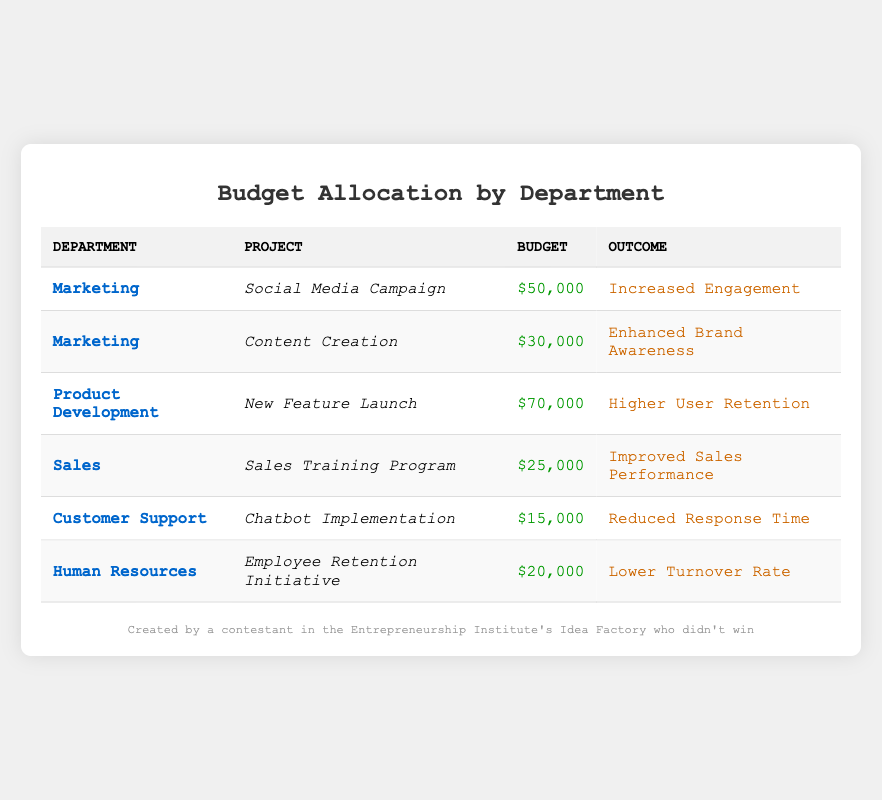What was the total budget allocated to the Marketing department? The Marketing department has two projects listed: the Social Media Campaign with a budget of 50,000 and Content Creation with a budget of 30,000. Adding these together gives 50,000 + 30,000 = 80,000.
Answer: 80,000 Which project had the lowest budget allocation? From the table, the Chatbot Implementation project from the Customer Support department had the lowest budget allocation of 15,000.
Answer: 15,000 Did the Product Development department have any project outcomes that improved user retention? Yes, the New Feature Launch project under the Product Development department had an outcome of higher user retention, which confirms this fact.
Answer: Yes What is the combined budget for projects that resulted in reduced response time or lower turnover rate? The Chatbot Implementation project had a budget of 15,000 (outcome: reduced response time) and the Employee Retention Initiative project had a budget of 20,000 (outcome: lower turnover rate). Adding these gives 15,000 + 20,000 = 35,000.
Answer: 35,000 Which department had a project with an outcome of improved sales performance, and what was the budget for it? The Sales department had a project titled Sales Training Program with a budget of 25,000, aimed at improving sales performance.
Answer: Sales, 25,000 Was the budget allocated for the Social Media Campaign greater than or equal to the budgets for all other projects combined? To evaluate this, the budget for the Social Media Campaign is 50,000. The sum of the other budgets is 30,000 (Content Creation) + 70,000 (New Feature Launch) + 25,000 (Sales Training Program) + 15,000 (Chatbot Implementation) + 20,000 (Employee Retention Initiative) = 160,000. Since 50,000 is less than 160,000, the answer is no.
Answer: No What was the average budget allocation for all projects listed in the table? There are six projects with the following budgets: 50,000, 30,000, 70,000, 25,000, 15,000, and 20,000. The total budget is 50,000 + 30,000 + 70,000 + 25,000 + 15,000 + 20,000 = 210,000. Dividing by the number of projects (6), we find that the average budget allocation is 210,000 / 6 = 35,000.
Answer: 35,000 How many projects had outcomes related to brand awareness or engagement? The Marketing department has two projects related to brand awareness (Content Creation) and engagement (Social Media Campaign). Therefore, there are a total of two such projects.
Answer: 2 Was the outcome for the Employee Retention Initiative associated with any measurable decrease in turnover? The outcome for the Employee Retention Initiative is explicitly stated as “Lower Turnover Rate,” which indicates a measurable decrease in turnover.
Answer: Yes 